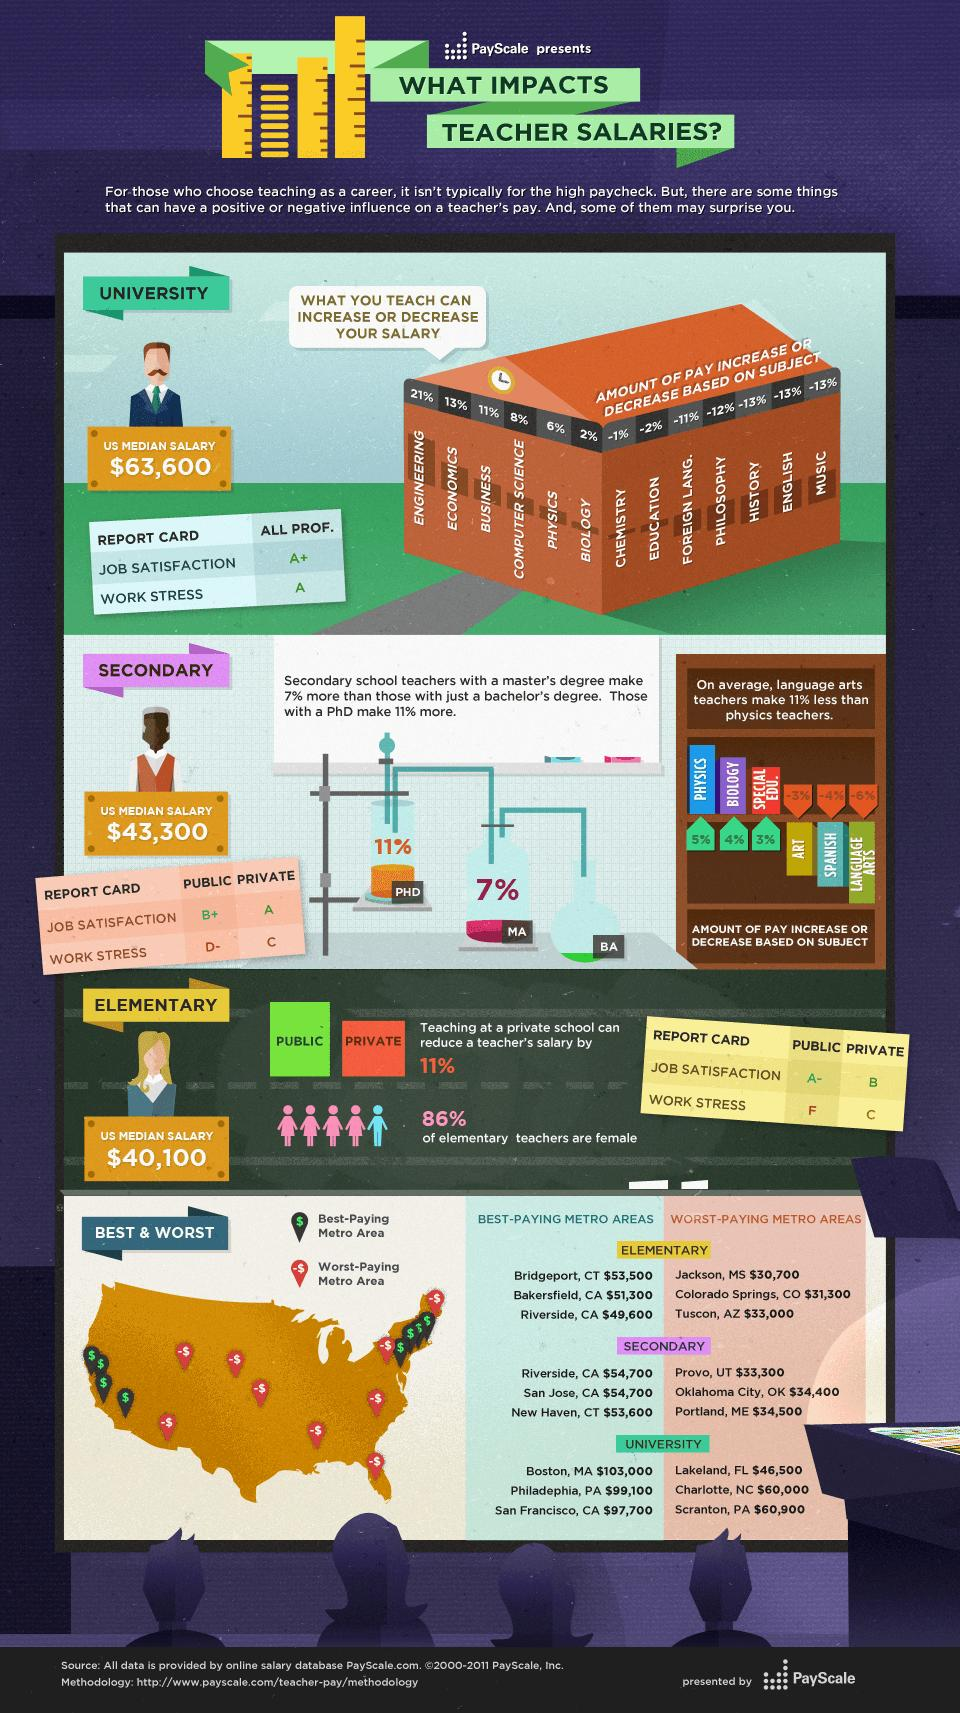Mention a couple of crucial points in this snapshot. California has the most number of top-paid elementary and secondary schools in the United States. In secondary schools, physics, biology, and special education teachers tend to earn a higher percentage of their pay compared to other teachers. The salary increase for business teachers varies depending on the percentage increase, whether it is 11%, a decrease of 11%, or 13%. If the increase is 11%, then the salary will be higher than before the increase. If the increase is a decrease of 11%, then the salary will be lower than before the decrease. If the increase is 13%, then the salary will be higher than before the increase, and the increase will be positive. The average lowest pay offered in secondary schools located in metro areas in the US is $34,066.66. The subjects of History, English, and Music have a 13% decrease in pay compared to other fields. 